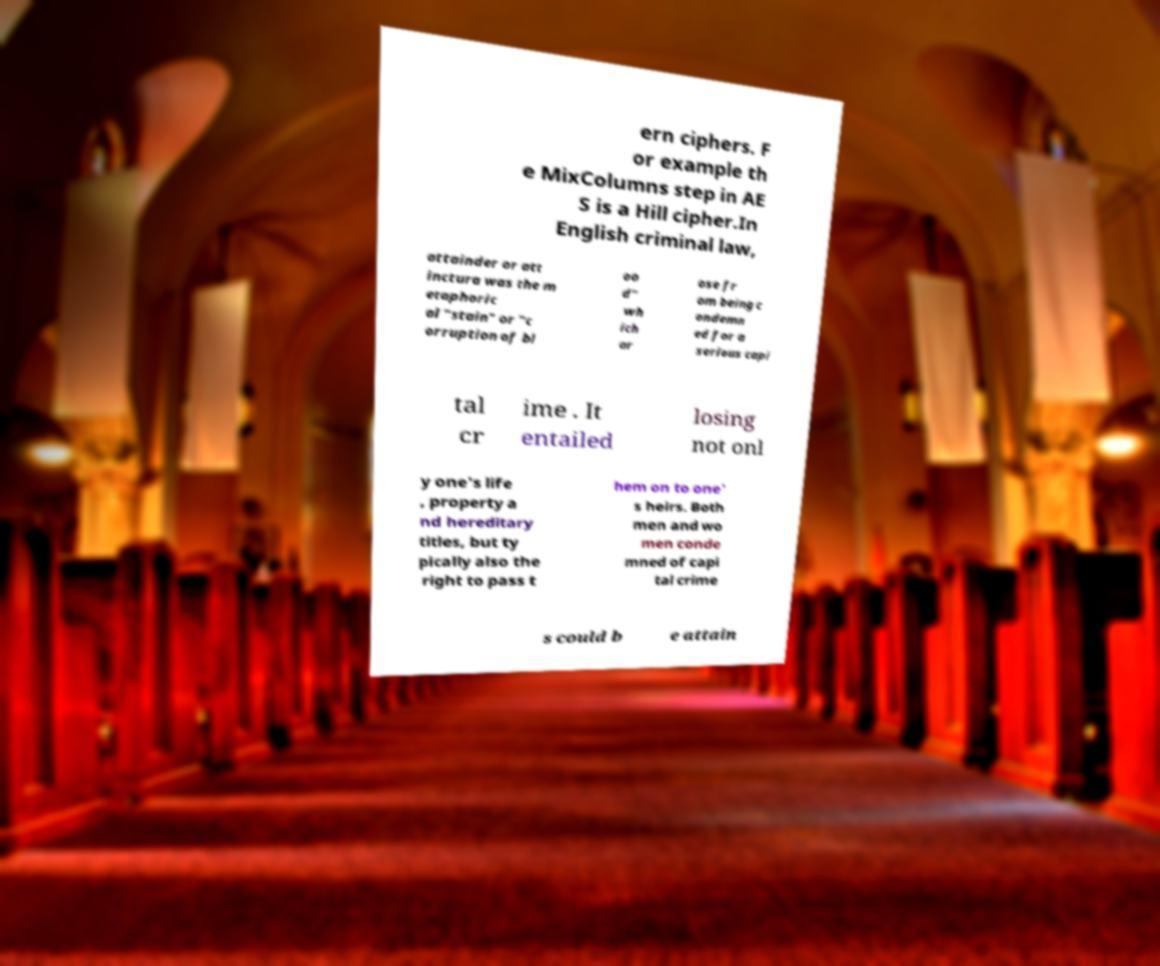Please read and relay the text visible in this image. What does it say? ern ciphers. F or example th e MixColumns step in AE S is a Hill cipher.In English criminal law, attainder or att inctura was the m etaphoric al "stain" or "c orruption of bl oo d" wh ich ar ose fr om being c ondemn ed for a serious capi tal cr ime . It entailed losing not onl y one's life , property a nd hereditary titles, but ty pically also the right to pass t hem on to one' s heirs. Both men and wo men conde mned of capi tal crime s could b e attain 